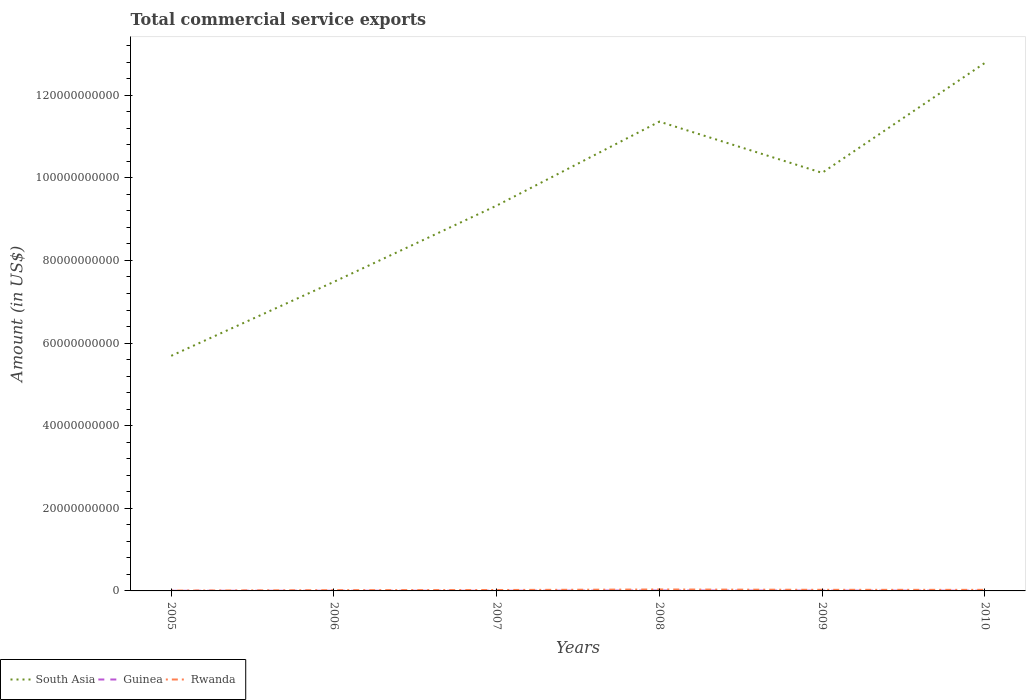How many different coloured lines are there?
Ensure brevity in your answer.  3. Does the line corresponding to Rwanda intersect with the line corresponding to South Asia?
Make the answer very short. No. Across all years, what is the maximum total commercial service exports in South Asia?
Ensure brevity in your answer.  5.69e+1. What is the total total commercial service exports in Rwanda in the graph?
Give a very brief answer. -1.04e+08. What is the difference between the highest and the second highest total commercial service exports in Guinea?
Your answer should be compact. 5.98e+07. What is the difference between the highest and the lowest total commercial service exports in Guinea?
Your response must be concise. 3. How many lines are there?
Provide a succinct answer. 3. What is the difference between two consecutive major ticks on the Y-axis?
Your answer should be very brief. 2.00e+1. Does the graph contain any zero values?
Keep it short and to the point. No. Does the graph contain grids?
Make the answer very short. No. Where does the legend appear in the graph?
Keep it short and to the point. Bottom left. How many legend labels are there?
Your answer should be very brief. 3. What is the title of the graph?
Your response must be concise. Total commercial service exports. What is the label or title of the Y-axis?
Your response must be concise. Amount (in US$). What is the Amount (in US$) in South Asia in 2005?
Keep it short and to the point. 5.69e+1. What is the Amount (in US$) of Guinea in 2005?
Your answer should be compact. 3.50e+07. What is the Amount (in US$) of Rwanda in 2005?
Provide a short and direct response. 8.22e+07. What is the Amount (in US$) in South Asia in 2006?
Ensure brevity in your answer.  7.48e+1. What is the Amount (in US$) of Guinea in 2006?
Ensure brevity in your answer.  3.78e+07. What is the Amount (in US$) in Rwanda in 2006?
Provide a succinct answer. 1.87e+08. What is the Amount (in US$) of South Asia in 2007?
Offer a terse response. 9.33e+1. What is the Amount (in US$) in Guinea in 2007?
Offer a terse response. 4.41e+07. What is the Amount (in US$) in Rwanda in 2007?
Your answer should be very brief. 2.22e+08. What is the Amount (in US$) of South Asia in 2008?
Offer a terse response. 1.14e+11. What is the Amount (in US$) in Guinea in 2008?
Your answer should be very brief. 9.48e+07. What is the Amount (in US$) in Rwanda in 2008?
Offer a terse response. 3.51e+08. What is the Amount (in US$) in South Asia in 2009?
Keep it short and to the point. 1.01e+11. What is the Amount (in US$) in Guinea in 2009?
Give a very brief answer. 6.69e+07. What is the Amount (in US$) of Rwanda in 2009?
Provide a succinct answer. 2.69e+08. What is the Amount (in US$) in South Asia in 2010?
Your answer should be compact. 1.28e+11. What is the Amount (in US$) in Guinea in 2010?
Your response must be concise. 6.08e+07. What is the Amount (in US$) of Rwanda in 2010?
Provide a succinct answer. 2.59e+08. Across all years, what is the maximum Amount (in US$) of South Asia?
Provide a succinct answer. 1.28e+11. Across all years, what is the maximum Amount (in US$) in Guinea?
Provide a short and direct response. 9.48e+07. Across all years, what is the maximum Amount (in US$) in Rwanda?
Offer a very short reply. 3.51e+08. Across all years, what is the minimum Amount (in US$) in South Asia?
Ensure brevity in your answer.  5.69e+1. Across all years, what is the minimum Amount (in US$) of Guinea?
Your answer should be compact. 3.50e+07. Across all years, what is the minimum Amount (in US$) in Rwanda?
Offer a terse response. 8.22e+07. What is the total Amount (in US$) of South Asia in the graph?
Provide a succinct answer. 5.68e+11. What is the total Amount (in US$) in Guinea in the graph?
Ensure brevity in your answer.  3.39e+08. What is the total Amount (in US$) of Rwanda in the graph?
Provide a short and direct response. 1.37e+09. What is the difference between the Amount (in US$) in South Asia in 2005 and that in 2006?
Give a very brief answer. -1.79e+1. What is the difference between the Amount (in US$) in Guinea in 2005 and that in 2006?
Your answer should be compact. -2.79e+06. What is the difference between the Amount (in US$) in Rwanda in 2005 and that in 2006?
Your answer should be very brief. -1.04e+08. What is the difference between the Amount (in US$) in South Asia in 2005 and that in 2007?
Your answer should be very brief. -3.64e+1. What is the difference between the Amount (in US$) in Guinea in 2005 and that in 2007?
Give a very brief answer. -9.09e+06. What is the difference between the Amount (in US$) in Rwanda in 2005 and that in 2007?
Offer a terse response. -1.40e+08. What is the difference between the Amount (in US$) of South Asia in 2005 and that in 2008?
Keep it short and to the point. -5.67e+1. What is the difference between the Amount (in US$) in Guinea in 2005 and that in 2008?
Your answer should be compact. -5.98e+07. What is the difference between the Amount (in US$) of Rwanda in 2005 and that in 2008?
Your answer should be very brief. -2.69e+08. What is the difference between the Amount (in US$) of South Asia in 2005 and that in 2009?
Provide a short and direct response. -4.43e+1. What is the difference between the Amount (in US$) in Guinea in 2005 and that in 2009?
Your answer should be very brief. -3.19e+07. What is the difference between the Amount (in US$) of Rwanda in 2005 and that in 2009?
Provide a short and direct response. -1.87e+08. What is the difference between the Amount (in US$) of South Asia in 2005 and that in 2010?
Provide a short and direct response. -7.09e+1. What is the difference between the Amount (in US$) of Guinea in 2005 and that in 2010?
Give a very brief answer. -2.58e+07. What is the difference between the Amount (in US$) in Rwanda in 2005 and that in 2010?
Make the answer very short. -1.77e+08. What is the difference between the Amount (in US$) of South Asia in 2006 and that in 2007?
Provide a succinct answer. -1.85e+1. What is the difference between the Amount (in US$) in Guinea in 2006 and that in 2007?
Your response must be concise. -6.30e+06. What is the difference between the Amount (in US$) in Rwanda in 2006 and that in 2007?
Your response must be concise. -3.54e+07. What is the difference between the Amount (in US$) in South Asia in 2006 and that in 2008?
Keep it short and to the point. -3.88e+1. What is the difference between the Amount (in US$) of Guinea in 2006 and that in 2008?
Provide a succinct answer. -5.70e+07. What is the difference between the Amount (in US$) of Rwanda in 2006 and that in 2008?
Your answer should be compact. -1.64e+08. What is the difference between the Amount (in US$) in South Asia in 2006 and that in 2009?
Make the answer very short. -2.64e+1. What is the difference between the Amount (in US$) in Guinea in 2006 and that in 2009?
Your answer should be compact. -2.91e+07. What is the difference between the Amount (in US$) in Rwanda in 2006 and that in 2009?
Offer a very short reply. -8.28e+07. What is the difference between the Amount (in US$) in South Asia in 2006 and that in 2010?
Offer a terse response. -5.30e+1. What is the difference between the Amount (in US$) of Guinea in 2006 and that in 2010?
Ensure brevity in your answer.  -2.30e+07. What is the difference between the Amount (in US$) of Rwanda in 2006 and that in 2010?
Offer a terse response. -7.28e+07. What is the difference between the Amount (in US$) of South Asia in 2007 and that in 2008?
Keep it short and to the point. -2.03e+1. What is the difference between the Amount (in US$) in Guinea in 2007 and that in 2008?
Your answer should be very brief. -5.07e+07. What is the difference between the Amount (in US$) in Rwanda in 2007 and that in 2008?
Provide a succinct answer. -1.29e+08. What is the difference between the Amount (in US$) of South Asia in 2007 and that in 2009?
Your answer should be very brief. -7.93e+09. What is the difference between the Amount (in US$) of Guinea in 2007 and that in 2009?
Provide a short and direct response. -2.28e+07. What is the difference between the Amount (in US$) in Rwanda in 2007 and that in 2009?
Offer a very short reply. -4.74e+07. What is the difference between the Amount (in US$) in South Asia in 2007 and that in 2010?
Provide a succinct answer. -3.45e+1. What is the difference between the Amount (in US$) in Guinea in 2007 and that in 2010?
Ensure brevity in your answer.  -1.67e+07. What is the difference between the Amount (in US$) in Rwanda in 2007 and that in 2010?
Provide a succinct answer. -3.73e+07. What is the difference between the Amount (in US$) in South Asia in 2008 and that in 2009?
Give a very brief answer. 1.24e+1. What is the difference between the Amount (in US$) in Guinea in 2008 and that in 2009?
Give a very brief answer. 2.79e+07. What is the difference between the Amount (in US$) of Rwanda in 2008 and that in 2009?
Offer a terse response. 8.14e+07. What is the difference between the Amount (in US$) in South Asia in 2008 and that in 2010?
Ensure brevity in your answer.  -1.42e+1. What is the difference between the Amount (in US$) of Guinea in 2008 and that in 2010?
Offer a very short reply. 3.40e+07. What is the difference between the Amount (in US$) of Rwanda in 2008 and that in 2010?
Your answer should be very brief. 9.14e+07. What is the difference between the Amount (in US$) in South Asia in 2009 and that in 2010?
Offer a terse response. -2.66e+1. What is the difference between the Amount (in US$) of Guinea in 2009 and that in 2010?
Your answer should be very brief. 6.08e+06. What is the difference between the Amount (in US$) in Rwanda in 2009 and that in 2010?
Keep it short and to the point. 1.00e+07. What is the difference between the Amount (in US$) of South Asia in 2005 and the Amount (in US$) of Guinea in 2006?
Provide a succinct answer. 5.69e+1. What is the difference between the Amount (in US$) of South Asia in 2005 and the Amount (in US$) of Rwanda in 2006?
Give a very brief answer. 5.67e+1. What is the difference between the Amount (in US$) of Guinea in 2005 and the Amount (in US$) of Rwanda in 2006?
Ensure brevity in your answer.  -1.52e+08. What is the difference between the Amount (in US$) in South Asia in 2005 and the Amount (in US$) in Guinea in 2007?
Keep it short and to the point. 5.69e+1. What is the difference between the Amount (in US$) of South Asia in 2005 and the Amount (in US$) of Rwanda in 2007?
Give a very brief answer. 5.67e+1. What is the difference between the Amount (in US$) in Guinea in 2005 and the Amount (in US$) in Rwanda in 2007?
Provide a short and direct response. -1.87e+08. What is the difference between the Amount (in US$) in South Asia in 2005 and the Amount (in US$) in Guinea in 2008?
Provide a succinct answer. 5.68e+1. What is the difference between the Amount (in US$) in South Asia in 2005 and the Amount (in US$) in Rwanda in 2008?
Make the answer very short. 5.66e+1. What is the difference between the Amount (in US$) in Guinea in 2005 and the Amount (in US$) in Rwanda in 2008?
Offer a very short reply. -3.16e+08. What is the difference between the Amount (in US$) in South Asia in 2005 and the Amount (in US$) in Guinea in 2009?
Give a very brief answer. 5.68e+1. What is the difference between the Amount (in US$) of South Asia in 2005 and the Amount (in US$) of Rwanda in 2009?
Make the answer very short. 5.66e+1. What is the difference between the Amount (in US$) of Guinea in 2005 and the Amount (in US$) of Rwanda in 2009?
Your response must be concise. -2.34e+08. What is the difference between the Amount (in US$) in South Asia in 2005 and the Amount (in US$) in Guinea in 2010?
Give a very brief answer. 5.69e+1. What is the difference between the Amount (in US$) of South Asia in 2005 and the Amount (in US$) of Rwanda in 2010?
Offer a very short reply. 5.67e+1. What is the difference between the Amount (in US$) of Guinea in 2005 and the Amount (in US$) of Rwanda in 2010?
Offer a terse response. -2.24e+08. What is the difference between the Amount (in US$) of South Asia in 2006 and the Amount (in US$) of Guinea in 2007?
Keep it short and to the point. 7.48e+1. What is the difference between the Amount (in US$) of South Asia in 2006 and the Amount (in US$) of Rwanda in 2007?
Keep it short and to the point. 7.46e+1. What is the difference between the Amount (in US$) of Guinea in 2006 and the Amount (in US$) of Rwanda in 2007?
Offer a very short reply. -1.84e+08. What is the difference between the Amount (in US$) of South Asia in 2006 and the Amount (in US$) of Guinea in 2008?
Your response must be concise. 7.47e+1. What is the difference between the Amount (in US$) in South Asia in 2006 and the Amount (in US$) in Rwanda in 2008?
Give a very brief answer. 7.45e+1. What is the difference between the Amount (in US$) in Guinea in 2006 and the Amount (in US$) in Rwanda in 2008?
Give a very brief answer. -3.13e+08. What is the difference between the Amount (in US$) in South Asia in 2006 and the Amount (in US$) in Guinea in 2009?
Provide a short and direct response. 7.48e+1. What is the difference between the Amount (in US$) of South Asia in 2006 and the Amount (in US$) of Rwanda in 2009?
Make the answer very short. 7.46e+1. What is the difference between the Amount (in US$) in Guinea in 2006 and the Amount (in US$) in Rwanda in 2009?
Your response must be concise. -2.32e+08. What is the difference between the Amount (in US$) of South Asia in 2006 and the Amount (in US$) of Guinea in 2010?
Provide a short and direct response. 7.48e+1. What is the difference between the Amount (in US$) of South Asia in 2006 and the Amount (in US$) of Rwanda in 2010?
Your answer should be very brief. 7.46e+1. What is the difference between the Amount (in US$) in Guinea in 2006 and the Amount (in US$) in Rwanda in 2010?
Provide a succinct answer. -2.22e+08. What is the difference between the Amount (in US$) of South Asia in 2007 and the Amount (in US$) of Guinea in 2008?
Ensure brevity in your answer.  9.32e+1. What is the difference between the Amount (in US$) in South Asia in 2007 and the Amount (in US$) in Rwanda in 2008?
Your answer should be compact. 9.29e+1. What is the difference between the Amount (in US$) in Guinea in 2007 and the Amount (in US$) in Rwanda in 2008?
Make the answer very short. -3.07e+08. What is the difference between the Amount (in US$) of South Asia in 2007 and the Amount (in US$) of Guinea in 2009?
Ensure brevity in your answer.  9.32e+1. What is the difference between the Amount (in US$) of South Asia in 2007 and the Amount (in US$) of Rwanda in 2009?
Keep it short and to the point. 9.30e+1. What is the difference between the Amount (in US$) of Guinea in 2007 and the Amount (in US$) of Rwanda in 2009?
Give a very brief answer. -2.25e+08. What is the difference between the Amount (in US$) of South Asia in 2007 and the Amount (in US$) of Guinea in 2010?
Your answer should be very brief. 9.32e+1. What is the difference between the Amount (in US$) in South Asia in 2007 and the Amount (in US$) in Rwanda in 2010?
Your answer should be compact. 9.30e+1. What is the difference between the Amount (in US$) in Guinea in 2007 and the Amount (in US$) in Rwanda in 2010?
Your response must be concise. -2.15e+08. What is the difference between the Amount (in US$) of South Asia in 2008 and the Amount (in US$) of Guinea in 2009?
Provide a short and direct response. 1.14e+11. What is the difference between the Amount (in US$) in South Asia in 2008 and the Amount (in US$) in Rwanda in 2009?
Ensure brevity in your answer.  1.13e+11. What is the difference between the Amount (in US$) in Guinea in 2008 and the Amount (in US$) in Rwanda in 2009?
Give a very brief answer. -1.75e+08. What is the difference between the Amount (in US$) of South Asia in 2008 and the Amount (in US$) of Guinea in 2010?
Keep it short and to the point. 1.14e+11. What is the difference between the Amount (in US$) in South Asia in 2008 and the Amount (in US$) in Rwanda in 2010?
Make the answer very short. 1.13e+11. What is the difference between the Amount (in US$) in Guinea in 2008 and the Amount (in US$) in Rwanda in 2010?
Keep it short and to the point. -1.65e+08. What is the difference between the Amount (in US$) of South Asia in 2009 and the Amount (in US$) of Guinea in 2010?
Offer a very short reply. 1.01e+11. What is the difference between the Amount (in US$) in South Asia in 2009 and the Amount (in US$) in Rwanda in 2010?
Your answer should be compact. 1.01e+11. What is the difference between the Amount (in US$) of Guinea in 2009 and the Amount (in US$) of Rwanda in 2010?
Offer a terse response. -1.92e+08. What is the average Amount (in US$) of South Asia per year?
Give a very brief answer. 9.46e+1. What is the average Amount (in US$) in Guinea per year?
Offer a very short reply. 5.66e+07. What is the average Amount (in US$) of Rwanda per year?
Offer a very short reply. 2.28e+08. In the year 2005, what is the difference between the Amount (in US$) in South Asia and Amount (in US$) in Guinea?
Give a very brief answer. 5.69e+1. In the year 2005, what is the difference between the Amount (in US$) of South Asia and Amount (in US$) of Rwanda?
Provide a short and direct response. 5.68e+1. In the year 2005, what is the difference between the Amount (in US$) of Guinea and Amount (in US$) of Rwanda?
Make the answer very short. -4.72e+07. In the year 2006, what is the difference between the Amount (in US$) in South Asia and Amount (in US$) in Guinea?
Ensure brevity in your answer.  7.48e+1. In the year 2006, what is the difference between the Amount (in US$) in South Asia and Amount (in US$) in Rwanda?
Provide a short and direct response. 7.46e+1. In the year 2006, what is the difference between the Amount (in US$) in Guinea and Amount (in US$) in Rwanda?
Provide a succinct answer. -1.49e+08. In the year 2007, what is the difference between the Amount (in US$) of South Asia and Amount (in US$) of Guinea?
Provide a succinct answer. 9.32e+1. In the year 2007, what is the difference between the Amount (in US$) of South Asia and Amount (in US$) of Rwanda?
Your answer should be very brief. 9.31e+1. In the year 2007, what is the difference between the Amount (in US$) in Guinea and Amount (in US$) in Rwanda?
Offer a very short reply. -1.78e+08. In the year 2008, what is the difference between the Amount (in US$) in South Asia and Amount (in US$) in Guinea?
Your answer should be very brief. 1.14e+11. In the year 2008, what is the difference between the Amount (in US$) of South Asia and Amount (in US$) of Rwanda?
Offer a terse response. 1.13e+11. In the year 2008, what is the difference between the Amount (in US$) of Guinea and Amount (in US$) of Rwanda?
Offer a very short reply. -2.56e+08. In the year 2009, what is the difference between the Amount (in US$) of South Asia and Amount (in US$) of Guinea?
Keep it short and to the point. 1.01e+11. In the year 2009, what is the difference between the Amount (in US$) of South Asia and Amount (in US$) of Rwanda?
Give a very brief answer. 1.01e+11. In the year 2009, what is the difference between the Amount (in US$) of Guinea and Amount (in US$) of Rwanda?
Give a very brief answer. -2.02e+08. In the year 2010, what is the difference between the Amount (in US$) in South Asia and Amount (in US$) in Guinea?
Give a very brief answer. 1.28e+11. In the year 2010, what is the difference between the Amount (in US$) in South Asia and Amount (in US$) in Rwanda?
Offer a very short reply. 1.28e+11. In the year 2010, what is the difference between the Amount (in US$) of Guinea and Amount (in US$) of Rwanda?
Offer a very short reply. -1.99e+08. What is the ratio of the Amount (in US$) of South Asia in 2005 to that in 2006?
Offer a very short reply. 0.76. What is the ratio of the Amount (in US$) in Guinea in 2005 to that in 2006?
Keep it short and to the point. 0.93. What is the ratio of the Amount (in US$) of Rwanda in 2005 to that in 2006?
Offer a terse response. 0.44. What is the ratio of the Amount (in US$) in South Asia in 2005 to that in 2007?
Offer a terse response. 0.61. What is the ratio of the Amount (in US$) in Guinea in 2005 to that in 2007?
Keep it short and to the point. 0.79. What is the ratio of the Amount (in US$) in Rwanda in 2005 to that in 2007?
Give a very brief answer. 0.37. What is the ratio of the Amount (in US$) of South Asia in 2005 to that in 2008?
Ensure brevity in your answer.  0.5. What is the ratio of the Amount (in US$) in Guinea in 2005 to that in 2008?
Provide a short and direct response. 0.37. What is the ratio of the Amount (in US$) of Rwanda in 2005 to that in 2008?
Make the answer very short. 0.23. What is the ratio of the Amount (in US$) of South Asia in 2005 to that in 2009?
Provide a short and direct response. 0.56. What is the ratio of the Amount (in US$) of Guinea in 2005 to that in 2009?
Offer a very short reply. 0.52. What is the ratio of the Amount (in US$) in Rwanda in 2005 to that in 2009?
Your answer should be compact. 0.31. What is the ratio of the Amount (in US$) of South Asia in 2005 to that in 2010?
Offer a very short reply. 0.45. What is the ratio of the Amount (in US$) in Guinea in 2005 to that in 2010?
Keep it short and to the point. 0.58. What is the ratio of the Amount (in US$) in Rwanda in 2005 to that in 2010?
Your answer should be very brief. 0.32. What is the ratio of the Amount (in US$) of South Asia in 2006 to that in 2007?
Your answer should be very brief. 0.8. What is the ratio of the Amount (in US$) of Guinea in 2006 to that in 2007?
Offer a terse response. 0.86. What is the ratio of the Amount (in US$) in Rwanda in 2006 to that in 2007?
Provide a succinct answer. 0.84. What is the ratio of the Amount (in US$) in South Asia in 2006 to that in 2008?
Your answer should be compact. 0.66. What is the ratio of the Amount (in US$) in Guinea in 2006 to that in 2008?
Keep it short and to the point. 0.4. What is the ratio of the Amount (in US$) of Rwanda in 2006 to that in 2008?
Keep it short and to the point. 0.53. What is the ratio of the Amount (in US$) of South Asia in 2006 to that in 2009?
Keep it short and to the point. 0.74. What is the ratio of the Amount (in US$) of Guinea in 2006 to that in 2009?
Ensure brevity in your answer.  0.57. What is the ratio of the Amount (in US$) in Rwanda in 2006 to that in 2009?
Offer a terse response. 0.69. What is the ratio of the Amount (in US$) of South Asia in 2006 to that in 2010?
Give a very brief answer. 0.59. What is the ratio of the Amount (in US$) of Guinea in 2006 to that in 2010?
Your response must be concise. 0.62. What is the ratio of the Amount (in US$) of Rwanda in 2006 to that in 2010?
Offer a terse response. 0.72. What is the ratio of the Amount (in US$) of South Asia in 2007 to that in 2008?
Your response must be concise. 0.82. What is the ratio of the Amount (in US$) of Guinea in 2007 to that in 2008?
Offer a very short reply. 0.47. What is the ratio of the Amount (in US$) in Rwanda in 2007 to that in 2008?
Keep it short and to the point. 0.63. What is the ratio of the Amount (in US$) of South Asia in 2007 to that in 2009?
Offer a terse response. 0.92. What is the ratio of the Amount (in US$) in Guinea in 2007 to that in 2009?
Provide a succinct answer. 0.66. What is the ratio of the Amount (in US$) of Rwanda in 2007 to that in 2009?
Ensure brevity in your answer.  0.82. What is the ratio of the Amount (in US$) of South Asia in 2007 to that in 2010?
Offer a very short reply. 0.73. What is the ratio of the Amount (in US$) of Guinea in 2007 to that in 2010?
Keep it short and to the point. 0.73. What is the ratio of the Amount (in US$) in Rwanda in 2007 to that in 2010?
Give a very brief answer. 0.86. What is the ratio of the Amount (in US$) in South Asia in 2008 to that in 2009?
Offer a very short reply. 1.12. What is the ratio of the Amount (in US$) in Guinea in 2008 to that in 2009?
Provide a succinct answer. 1.42. What is the ratio of the Amount (in US$) of Rwanda in 2008 to that in 2009?
Provide a succinct answer. 1.3. What is the ratio of the Amount (in US$) in Guinea in 2008 to that in 2010?
Give a very brief answer. 1.56. What is the ratio of the Amount (in US$) in Rwanda in 2008 to that in 2010?
Your answer should be very brief. 1.35. What is the ratio of the Amount (in US$) in South Asia in 2009 to that in 2010?
Ensure brevity in your answer.  0.79. What is the ratio of the Amount (in US$) in Rwanda in 2009 to that in 2010?
Your answer should be compact. 1.04. What is the difference between the highest and the second highest Amount (in US$) of South Asia?
Your response must be concise. 1.42e+1. What is the difference between the highest and the second highest Amount (in US$) in Guinea?
Offer a very short reply. 2.79e+07. What is the difference between the highest and the second highest Amount (in US$) in Rwanda?
Ensure brevity in your answer.  8.14e+07. What is the difference between the highest and the lowest Amount (in US$) of South Asia?
Provide a succinct answer. 7.09e+1. What is the difference between the highest and the lowest Amount (in US$) of Guinea?
Your answer should be compact. 5.98e+07. What is the difference between the highest and the lowest Amount (in US$) of Rwanda?
Keep it short and to the point. 2.69e+08. 